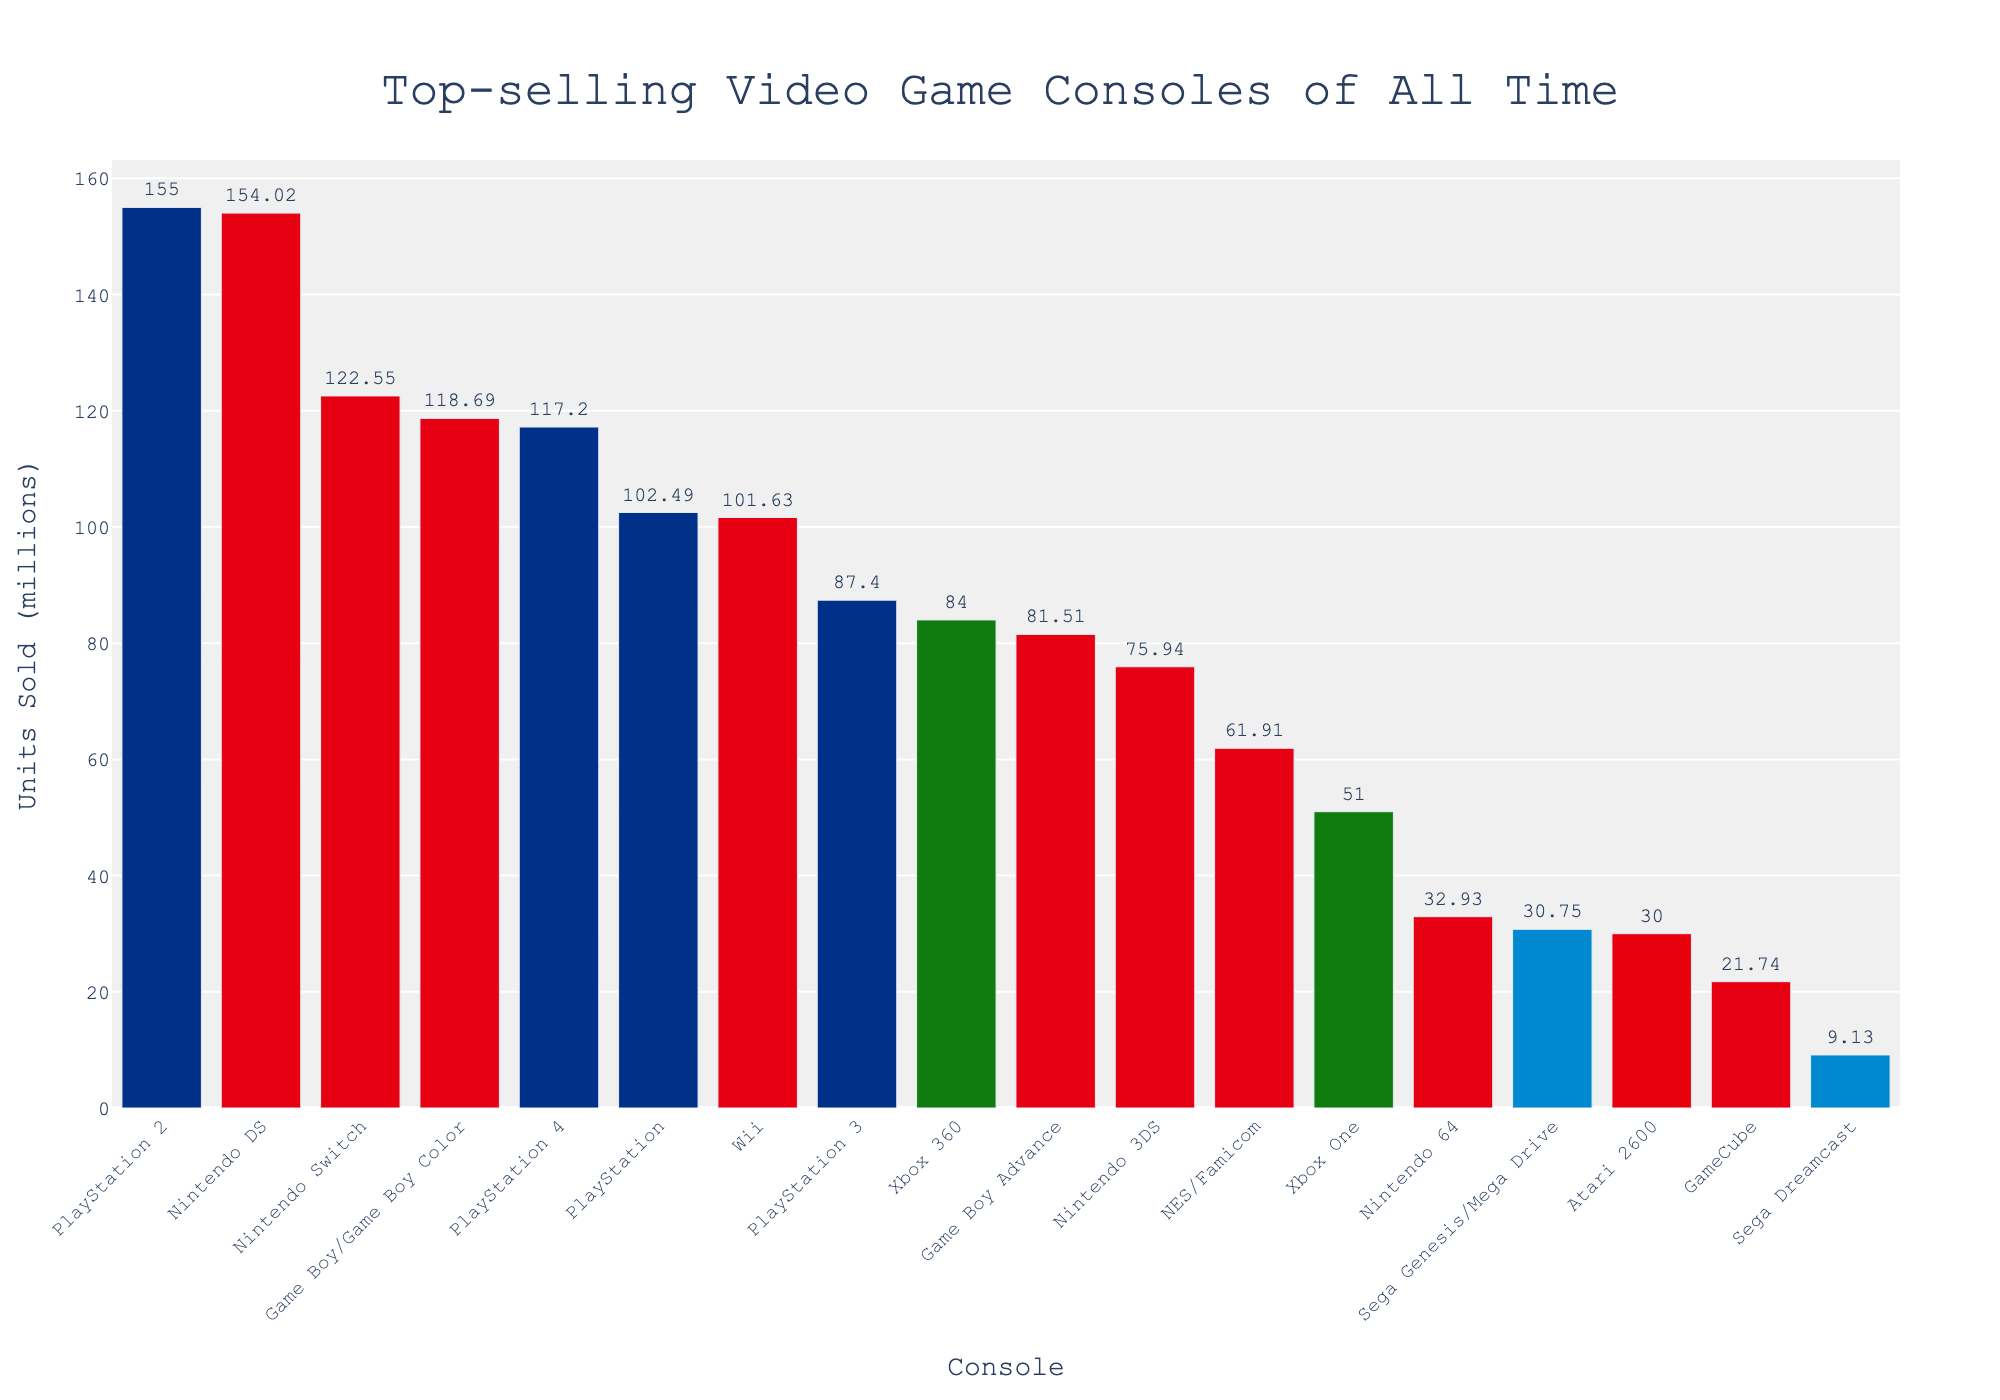Which console has the highest units sold? The bar with the highest value represents the console with the most units sold. The PlayStation 2 bar is taller than all others, indicating it has the highest sales.
Answer: PlayStation 2 Which two consoles sold the least units? By comparing the heights of all bars, the Sega Dreamcast and GameCube have the shortest bars, indicating the lowest sales.
Answer: Sega Dreamcast, GameCube What is the combined unit sales of Nintendo DS and Nintendo Switch? Find the bars labeled "Nintendo DS" and "Nintendo Switch", then add their values: 154.02 million + 122.55 million = 276.57 million units.
Answer: 276.57 million How many Nintendo consoles are in the top five best-selling consoles? Identify and count the Nintendo consoles within the top five highest bars: Nintendo DS, Game Boy/Game Boy Color, and Nintendo Switch.
Answer: 3 Which Sony console is almost equal in sales to Nintendo Switch? Compare bar heights and values of Sony consoles to Nintendo Switch (122.55 million). PlayStation 4 with 117.2 million units is closest.
Answer: PlayStation 4 What is the average number of units sold across all Microsoft consoles listed? Sum units sold for Microsoft consoles (Xbox 360: 84 million, Xbox One: 51 million), then divide by the number of Microsoft consoles (2). (84 + 51) / 2 = 67.5 million units.
Answer: 67.5 million Which consoles have sales between 50 million and 100 million units? Identify bars where values fall between 50 and 100 million: Wii (101.63 million) and PlayStation (102.49 million) are slightly above, so the valid consoles are Xbox 360, PlayStation 3, Game Boy Advance, and Nintendo 3DS.
Answer: Xbox 360, PlayStation 3, Game Boy Advance, Nintendo 3DS Between Microsoft and Sega, which manufacturer sold more units in total? Calculate total units sold by summing each manufacturer's bars: Microsoft (84 + 51 = 135 million), Sega (30.75 + 9.13 = 39.88 million). Microsoft clearly sold more.
Answer: Microsoft Which console's bar is colored green? Identify the manufacturer Microsoft's color (green): Xbox 360 and Xbox One are colored green.
Answer: Xbox 360, Xbox One What's the difference in units sold between the Nintendo Wii and Sega Genesis/Mega Drive? Subtract Sega Genesis/Mega Drive sales from Wii sales: 101.63 million - 30.75 million = 70.88 million units.
Answer: 70.88 million 